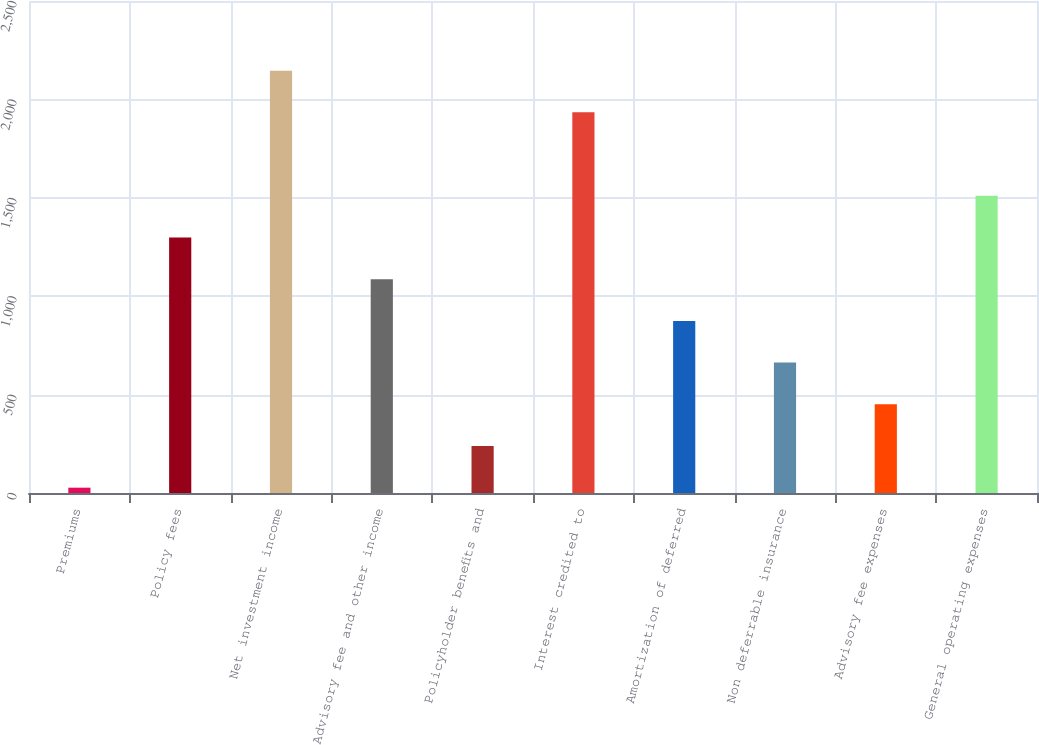Convert chart to OTSL. <chart><loc_0><loc_0><loc_500><loc_500><bar_chart><fcel>Premiums<fcel>Policy fees<fcel>Net investment income<fcel>Advisory fee and other income<fcel>Policyholder benefits and<fcel>Interest credited to<fcel>Amortization of deferred<fcel>Non deferrable insurance<fcel>Advisory fee expenses<fcel>General operating expenses<nl><fcel>27<fcel>1298.4<fcel>2146<fcel>1086.5<fcel>238.9<fcel>1934.1<fcel>874.6<fcel>662.7<fcel>450.8<fcel>1510.3<nl></chart> 